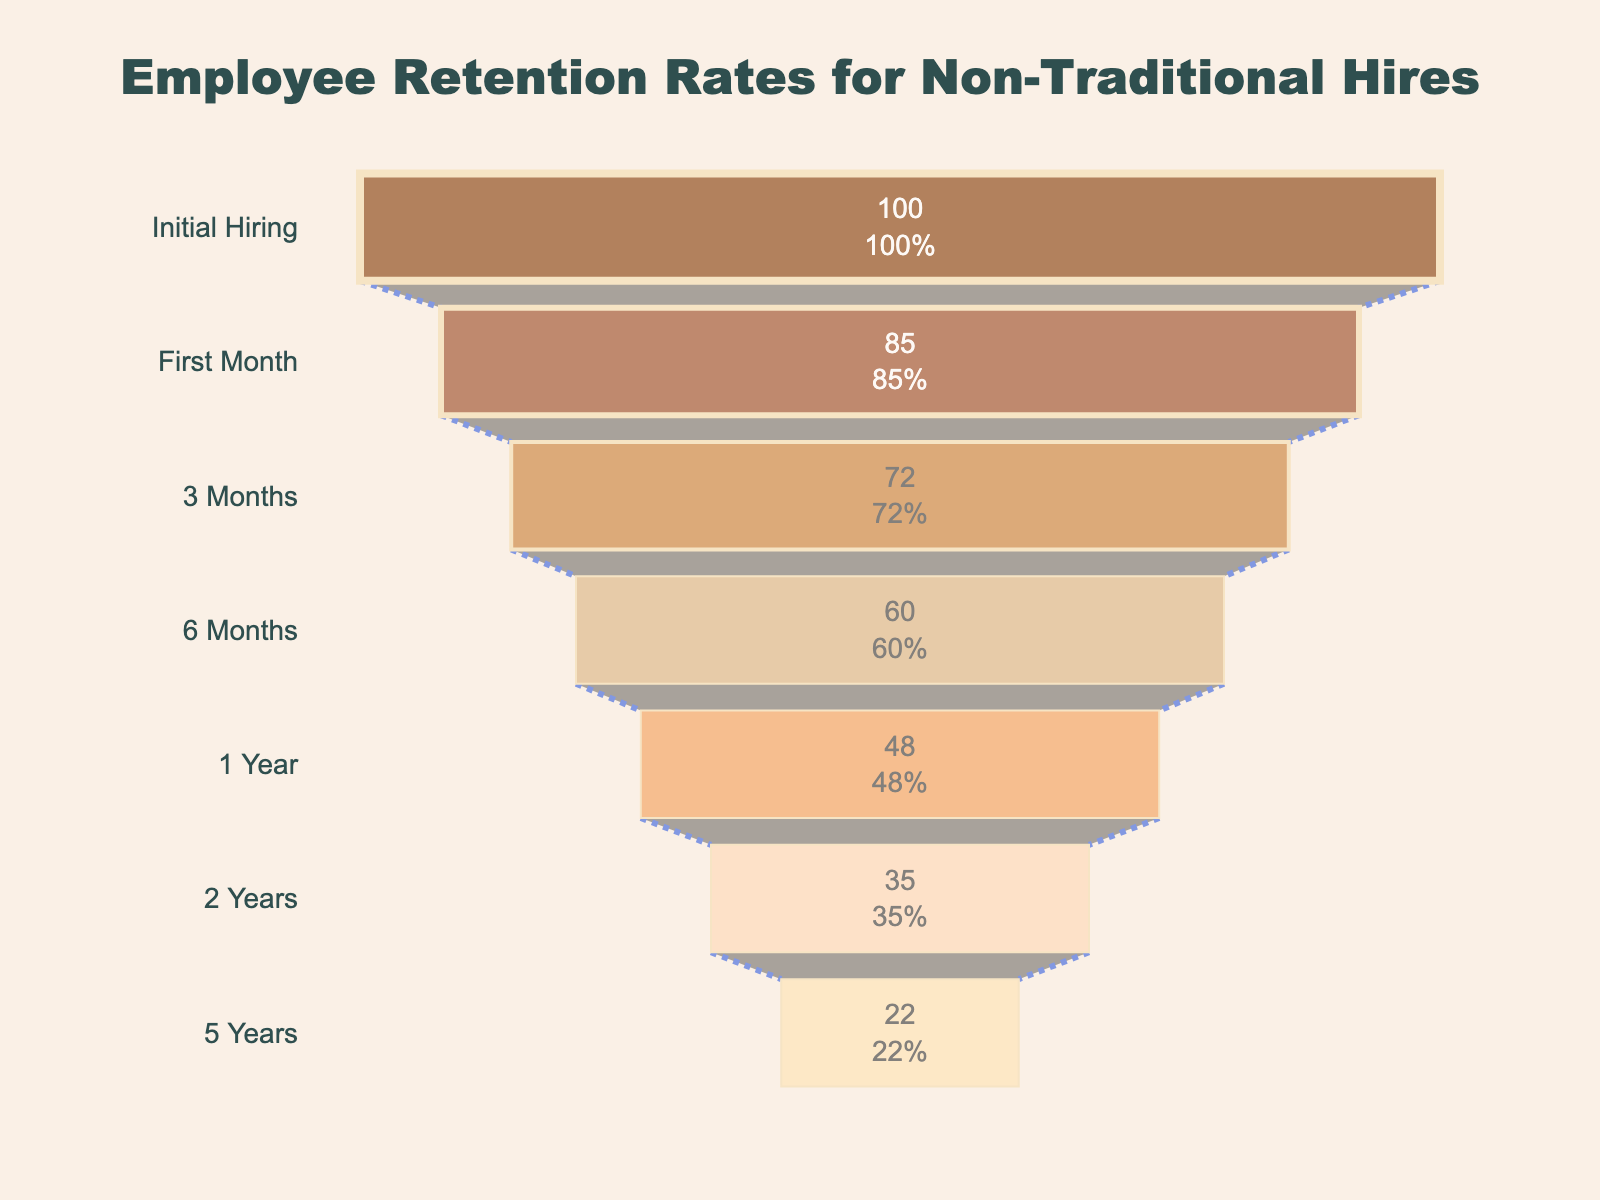How many stages are listed in the funnel chart? Count the number of stages listed on the y-axis of the funnel chart.
Answer: 7 What is the retention rate after the first month? Look at the retention rate value corresponding to the "First Month" stage on the y-axis.
Answer: 85% Which stage has the lowest retention rate? Identify the stage with the smallest retention rate value displayed on the x-axis.
Answer: 5 Years What is the difference in retention rates between the 3 Months stage and the 2 Years stage? Subtract the retention rate at the "2 Years" stage from the retention rate at the "3 Months" stage.
Answer: 37% What is the average retention rate from Initial Hiring to 6 Months? Sum the retention rates for Initial Hiring, First Month, 3 Months, and 6 Months. Then divide by the number of stages (4).
Answer: 79.25% Is the retention rate after 1 Year greater than or less than 50%? Look at the retention rate value for the "1 Year" stage and compare it to 50%.
Answer: Less than 50% Between which two consecutive stages is the biggest drop in retention rate observed? Calculate the retention rate drop for each pair of consecutive stages and identify the pair with the largest difference.
Answer: Initial Hiring to First Month What's the retention rate percentage loss from Initial Hiring to 1 Year? Subtract the retention rate at the "1 Year" stage from the retention rate at the "Initial Hiring" stage.
Answer: 52% How does the retention rate trend over time for the listed stages? Observe the general trend of the retention rates across all stages from the funnel chart, noting decreases at each stage.
Answer: Decreasing 